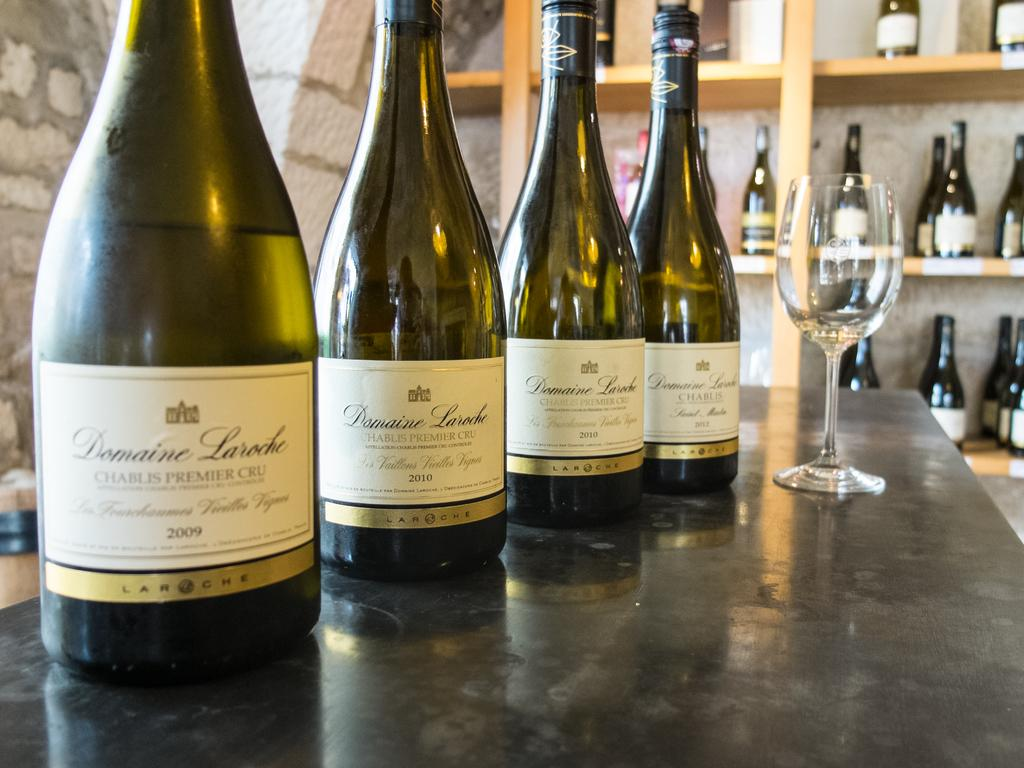<image>
Write a terse but informative summary of the picture. Four green bottles of Domaine Laroche printed on it atop a marble counter. 